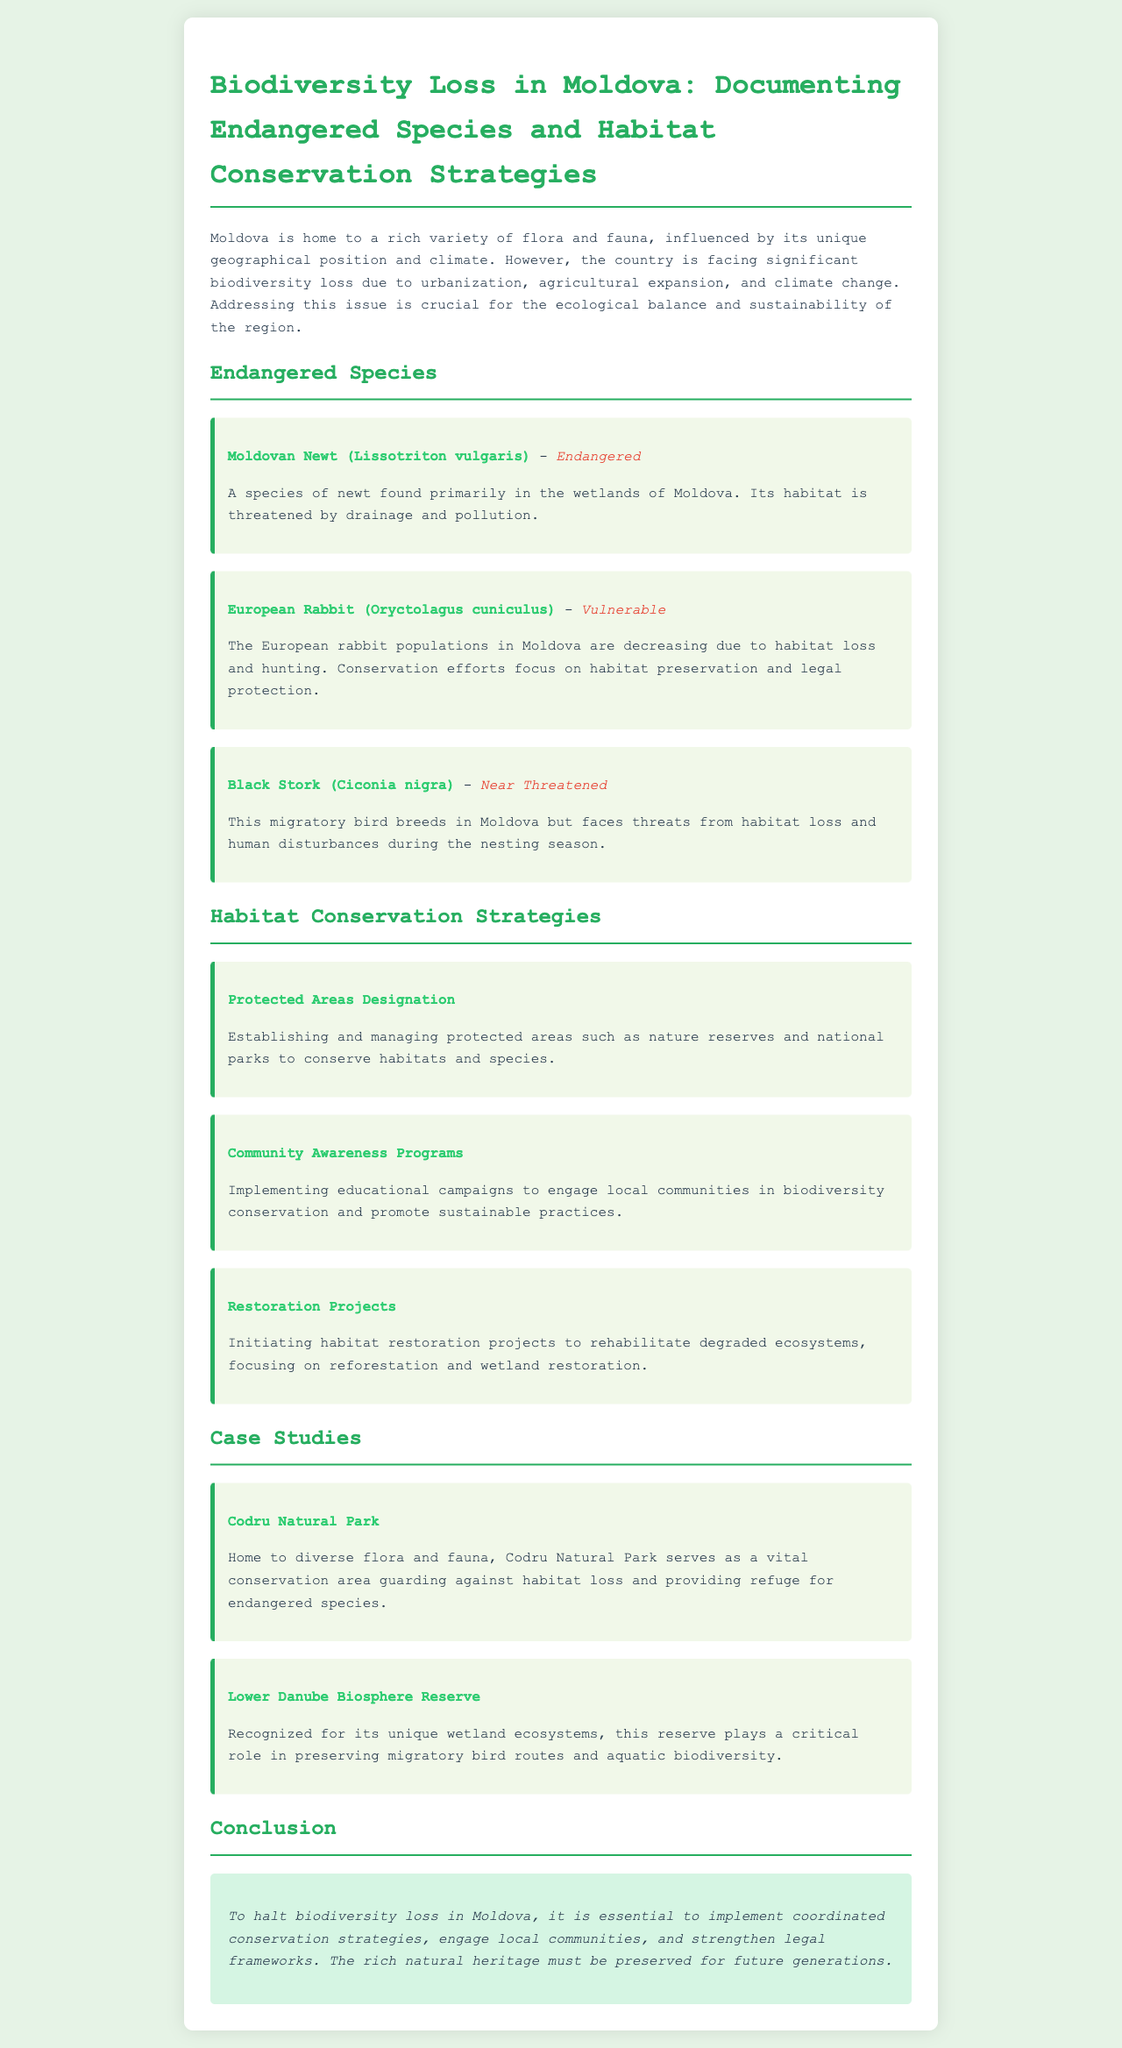What is the status of the Moldovan Newt? The Moldovan Newt is categorized as endangered in the document.
Answer: Endangered What is the main threat to the European Rabbit? The European Rabbit faces threats primarily due to habitat loss and hunting.
Answer: Habitat loss and hunting Which conservation strategy focuses on local community engagement? Community Awareness Programs aim to engage local communities in conservation efforts.
Answer: Community Awareness Programs What is the name of the protected area that serves as a vital conservation area? Codru Natural Park is mentioned as a critical conservation area in the document.
Answer: Codru Natural Park How many endangered species are listed in the document? The document lists three endangered species.
Answer: Three What role does the Lower Danube Biosphere Reserve play in biodiversity preservation? The Lower Danube Biosphere Reserve preserves migratory bird routes and aquatic biodiversity.
Answer: Preserves migratory bird routes and aquatic biodiversity What is the conclusion regarding biodiversity loss in Moldova? The conclusion emphasizes the need for coordinated conservation strategies and community engagement.
Answer: Need for coordinated conservation strategies and community engagement What type of species is the Black Stork classified as according to the document? The Black Stork is classified as near threatened.
Answer: Near Threatened 